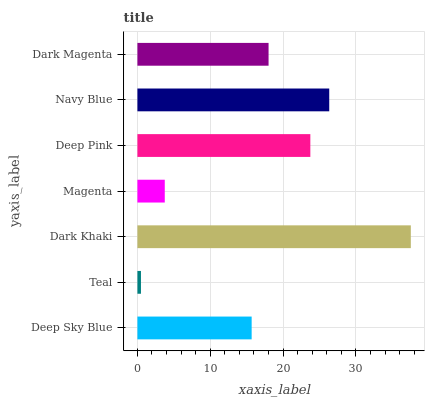Is Teal the minimum?
Answer yes or no. Yes. Is Dark Khaki the maximum?
Answer yes or no. Yes. Is Dark Khaki the minimum?
Answer yes or no. No. Is Teal the maximum?
Answer yes or no. No. Is Dark Khaki greater than Teal?
Answer yes or no. Yes. Is Teal less than Dark Khaki?
Answer yes or no. Yes. Is Teal greater than Dark Khaki?
Answer yes or no. No. Is Dark Khaki less than Teal?
Answer yes or no. No. Is Dark Magenta the high median?
Answer yes or no. Yes. Is Dark Magenta the low median?
Answer yes or no. Yes. Is Navy Blue the high median?
Answer yes or no. No. Is Navy Blue the low median?
Answer yes or no. No. 